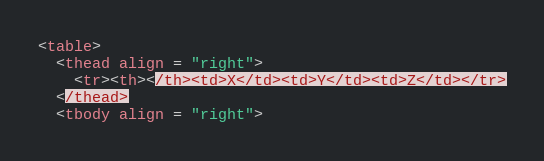<code> <loc_0><loc_0><loc_500><loc_500><_Awk_><table>
  <thead align = "right">
    <tr><th></th><td>X</td><td>Y</td><td>Z</td></tr>
  </thead>
  <tbody align = "right"></code> 